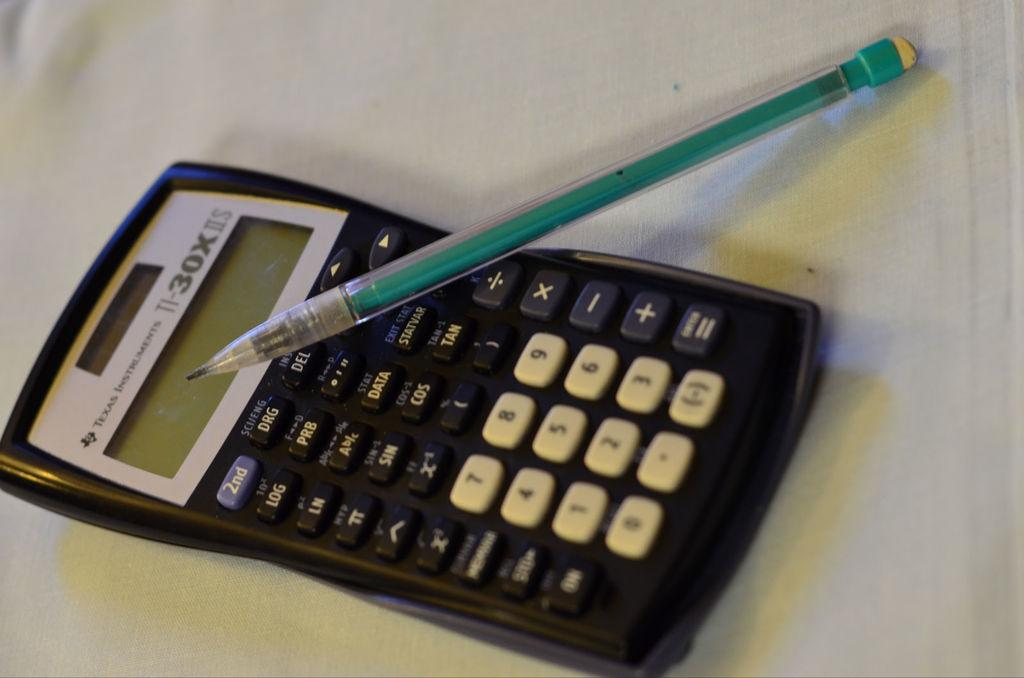What is the main object in the image? There is a calculator in the image. What other object is present in the image? There is a pencil in the image. Where are the calculator and pencil located? Both the calculator and pencil are placed on a table. How far away is the uncle from the table in the image? There is no uncle present in the image, so it is not possible to determine the distance between an uncle and the table. 